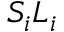<formula> <loc_0><loc_0><loc_500><loc_500>S _ { i } L _ { i }</formula> 